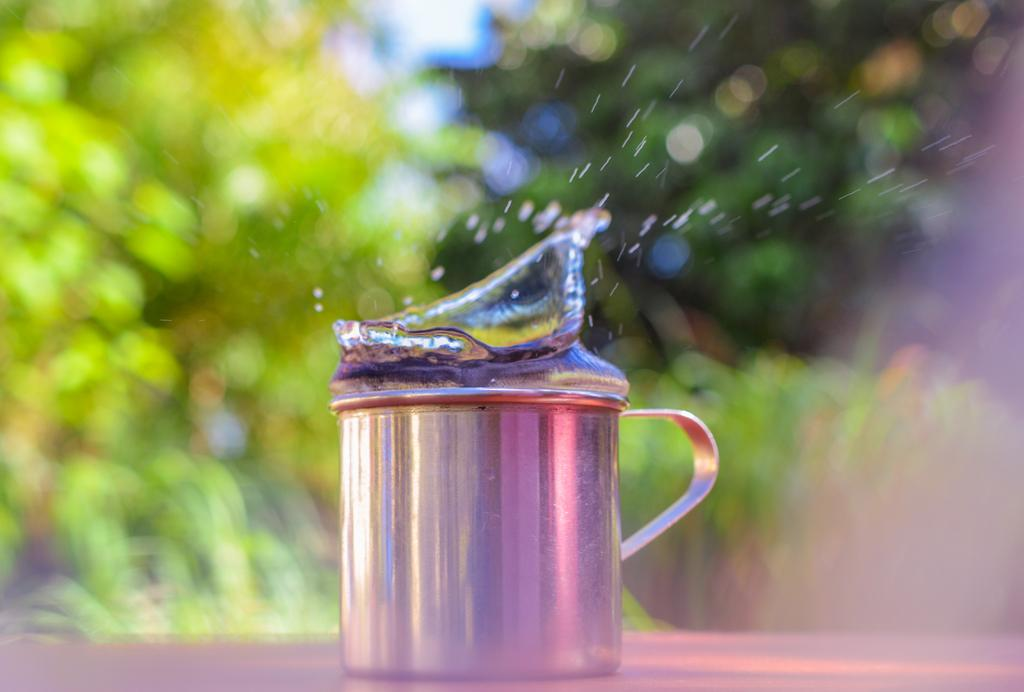What is in the mug that is visible in the image? There is a mug with liquid in the image. Can you describe the background of the image? The background of the image is blurred. What type of natural environment is visible in the background of the image? There is greenery visible in the background of the image. How does the drain affect the liquid in the mug in the image? There is no drain present in the image, so it does not affect the liquid in the mug. What type of magic is being performed with the mug in the image? There is no magic present in the image; it is a mug with liquid in it. 